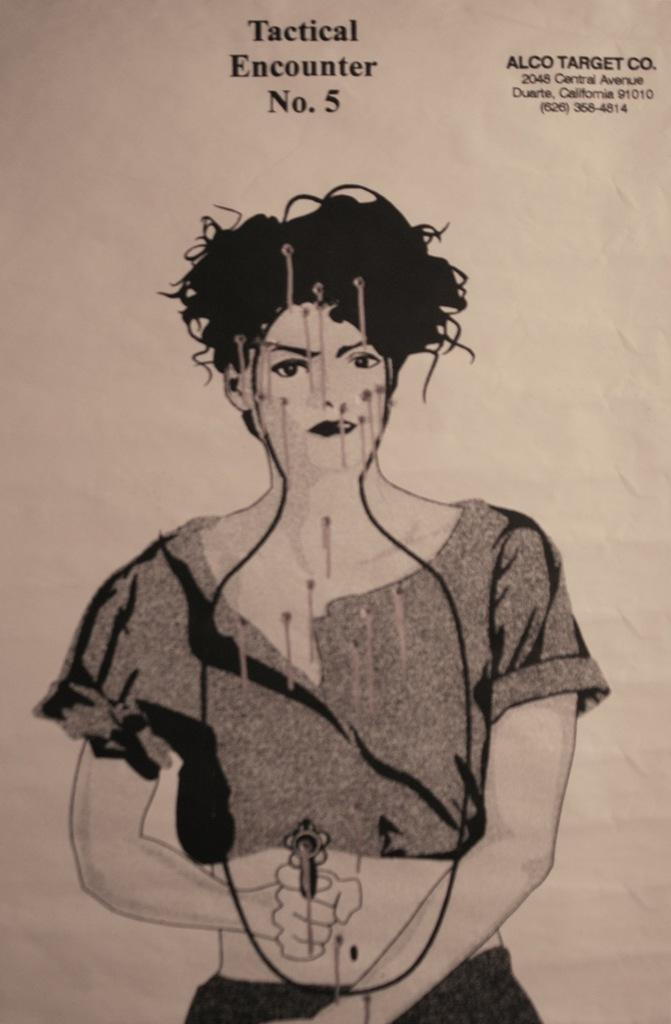What is the main subject of the picture? The main subject of the picture is a printed image. Can you describe any text that is present in the picture? Yes, there is text at the top of the picture and text at the top right corner of the picture. What flavor of destruction is depicted in the image? There is no destruction depicted in the image, and therefore no flavor can be identified. 